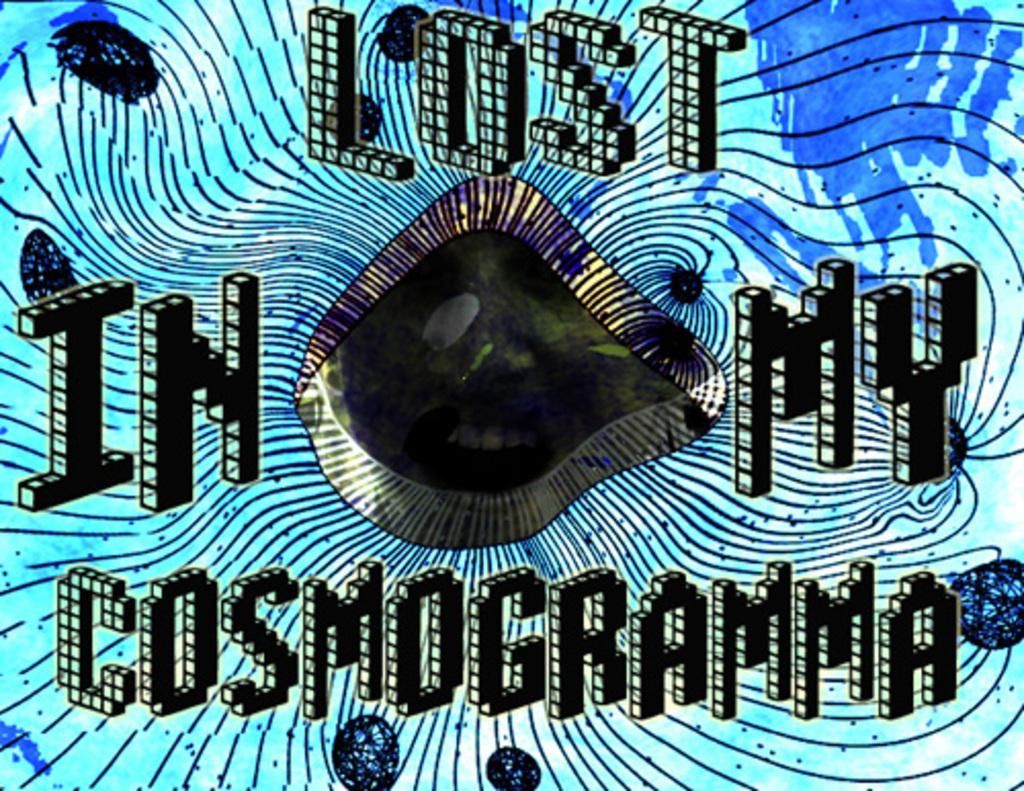<image>
Offer a succinct explanation of the picture presented. The unidentifiable face peers out from a blue and black graphic proclaiming, "Lost in my cosmogramma." 